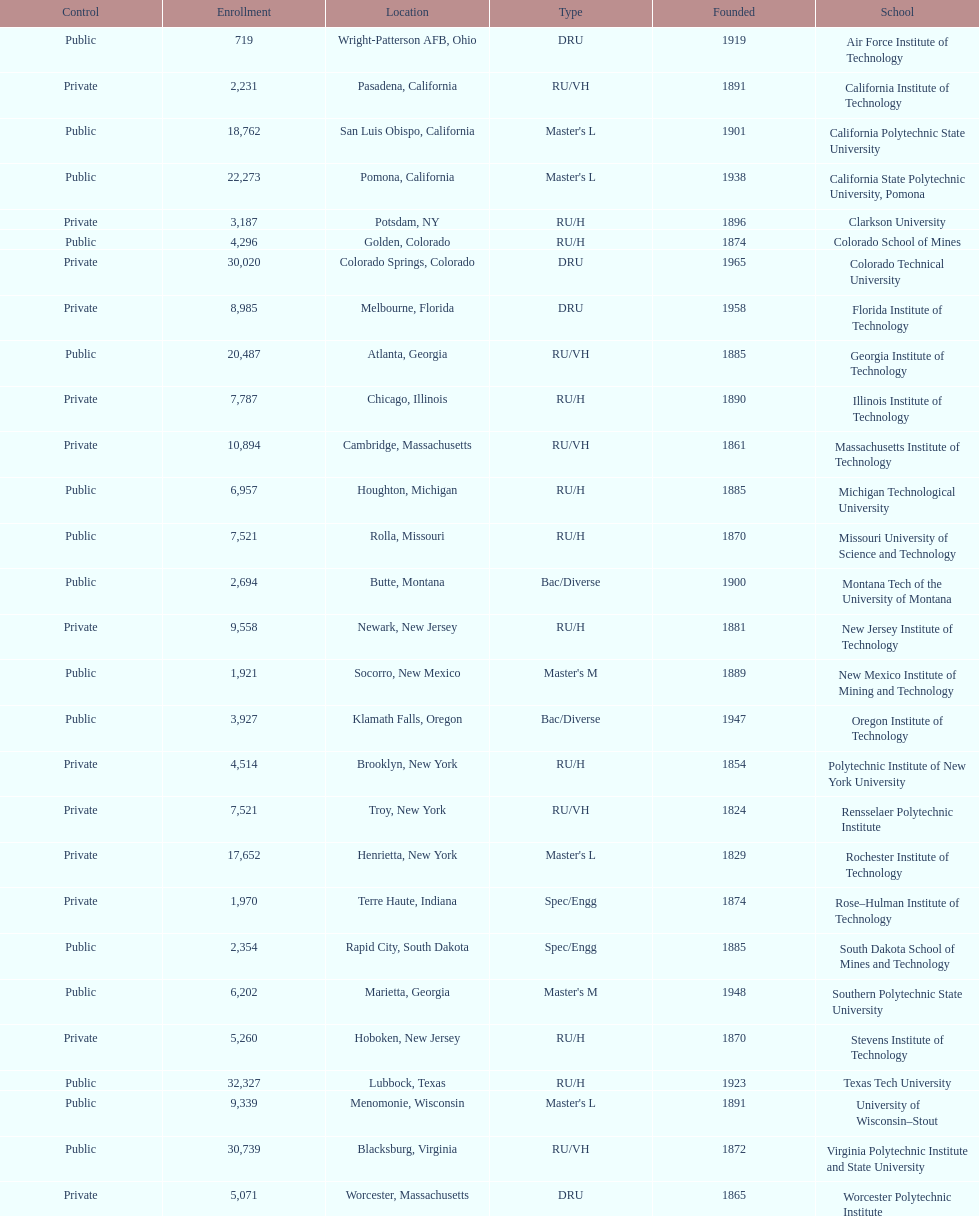Which us technological university has the top enrollment numbers? Texas Tech University. 